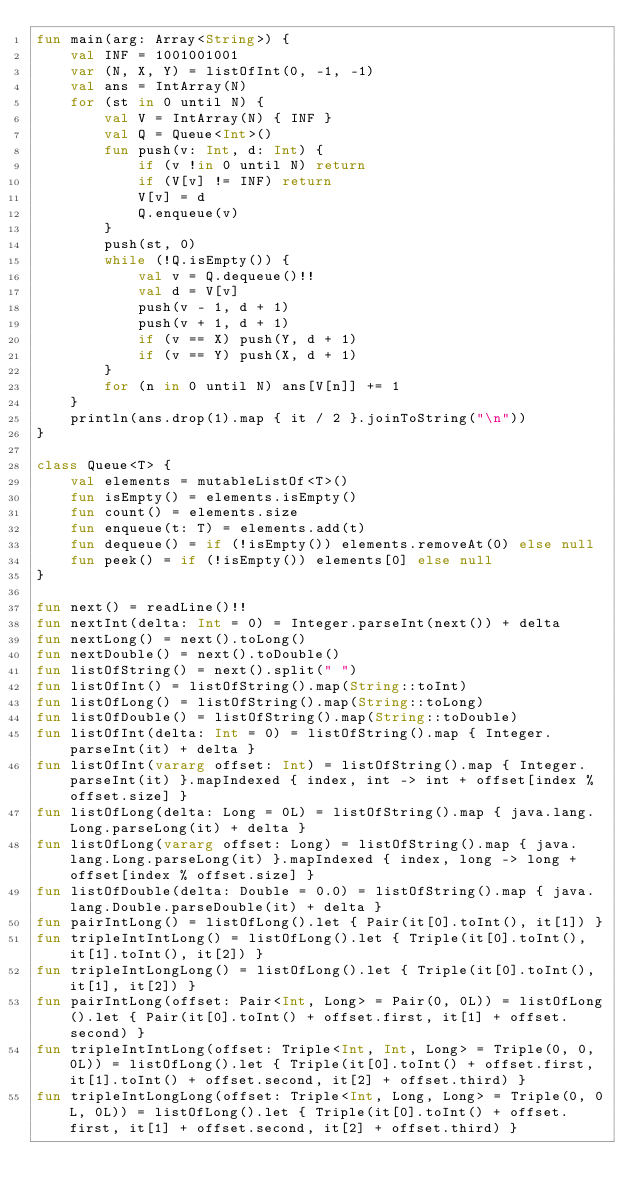Convert code to text. <code><loc_0><loc_0><loc_500><loc_500><_Kotlin_>fun main(arg: Array<String>) {
    val INF = 1001001001
    var (N, X, Y) = listOfInt(0, -1, -1)
    val ans = IntArray(N)
    for (st in 0 until N) {
        val V = IntArray(N) { INF }
        val Q = Queue<Int>()
        fun push(v: Int, d: Int) {
            if (v !in 0 until N) return
            if (V[v] != INF) return
            V[v] = d
            Q.enqueue(v)
        }
        push(st, 0)
        while (!Q.isEmpty()) {
            val v = Q.dequeue()!!
            val d = V[v]
            push(v - 1, d + 1)
            push(v + 1, d + 1)
            if (v == X) push(Y, d + 1)
            if (v == Y) push(X, d + 1)
        }
        for (n in 0 until N) ans[V[n]] += 1
    }
    println(ans.drop(1).map { it / 2 }.joinToString("\n"))
}

class Queue<T> {
    val elements = mutableListOf<T>()
    fun isEmpty() = elements.isEmpty()
    fun count() = elements.size
    fun enqueue(t: T) = elements.add(t)
    fun dequeue() = if (!isEmpty()) elements.removeAt(0) else null
    fun peek() = if (!isEmpty()) elements[0] else null
}

fun next() = readLine()!!
fun nextInt(delta: Int = 0) = Integer.parseInt(next()) + delta
fun nextLong() = next().toLong()
fun nextDouble() = next().toDouble()
fun listOfString() = next().split(" ")
fun listOfInt() = listOfString().map(String::toInt)
fun listOfLong() = listOfString().map(String::toLong)
fun listOfDouble() = listOfString().map(String::toDouble)
fun listOfInt(delta: Int = 0) = listOfString().map { Integer.parseInt(it) + delta }
fun listOfInt(vararg offset: Int) = listOfString().map { Integer.parseInt(it) }.mapIndexed { index, int -> int + offset[index % offset.size] }
fun listOfLong(delta: Long = 0L) = listOfString().map { java.lang.Long.parseLong(it) + delta }
fun listOfLong(vararg offset: Long) = listOfString().map { java.lang.Long.parseLong(it) }.mapIndexed { index, long -> long + offset[index % offset.size] }
fun listOfDouble(delta: Double = 0.0) = listOfString().map { java.lang.Double.parseDouble(it) + delta }
fun pairIntLong() = listOfLong().let { Pair(it[0].toInt(), it[1]) }
fun tripleIntIntLong() = listOfLong().let { Triple(it[0].toInt(), it[1].toInt(), it[2]) }
fun tripleIntLongLong() = listOfLong().let { Triple(it[0].toInt(), it[1], it[2]) }
fun pairIntLong(offset: Pair<Int, Long> = Pair(0, 0L)) = listOfLong().let { Pair(it[0].toInt() + offset.first, it[1] + offset.second) }
fun tripleIntIntLong(offset: Triple<Int, Int, Long> = Triple(0, 0, 0L)) = listOfLong().let { Triple(it[0].toInt() + offset.first, it[1].toInt() + offset.second, it[2] + offset.third) }
fun tripleIntLongLong(offset: Triple<Int, Long, Long> = Triple(0, 0L, 0L)) = listOfLong().let { Triple(it[0].toInt() + offset.first, it[1] + offset.second, it[2] + offset.third) }

</code> 